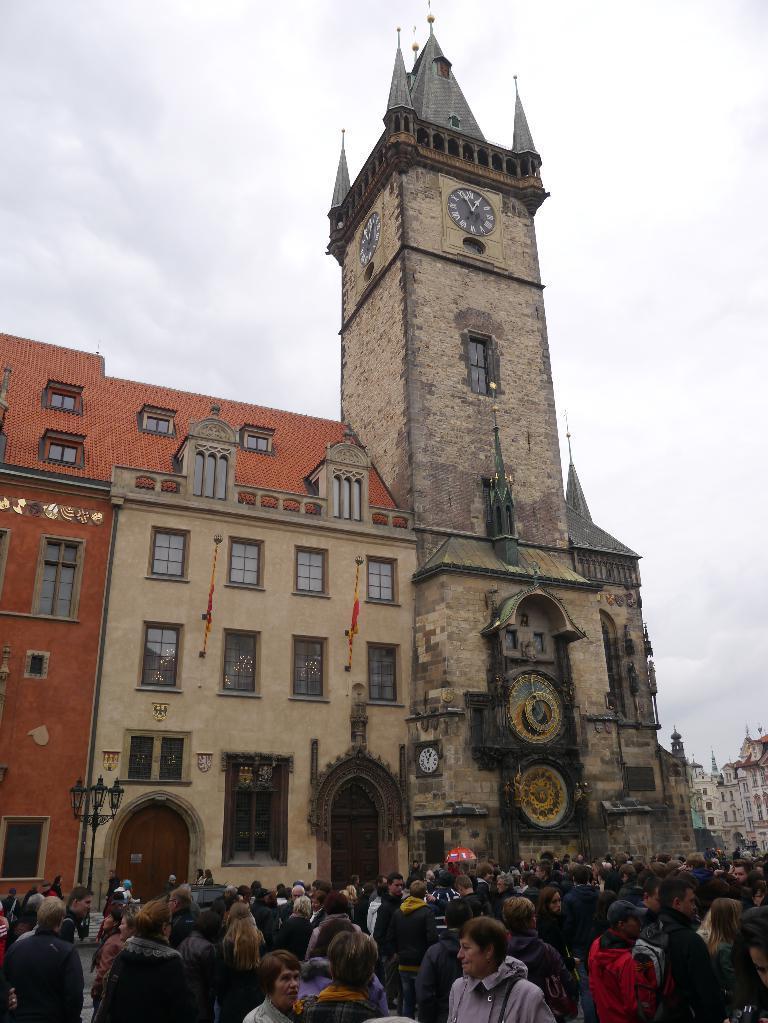Could you give a brief overview of what you see in this image? In this image, we can see persons wearing clothes. There is a building in the middle of the image. There is a sky at the top of the image. 